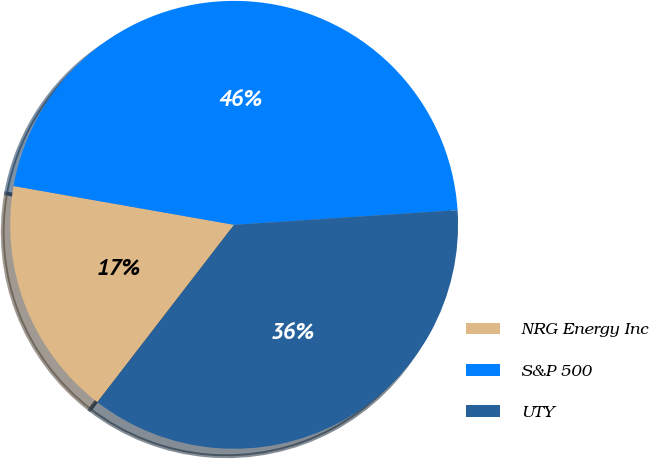Convert chart. <chart><loc_0><loc_0><loc_500><loc_500><pie_chart><fcel>NRG Energy Inc<fcel>S&P 500<fcel>UTY<nl><fcel>17.32%<fcel>46.19%<fcel>36.5%<nl></chart> 